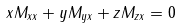<formula> <loc_0><loc_0><loc_500><loc_500>x M _ { x x } + y M _ { y x } + z M _ { z x } = 0</formula> 